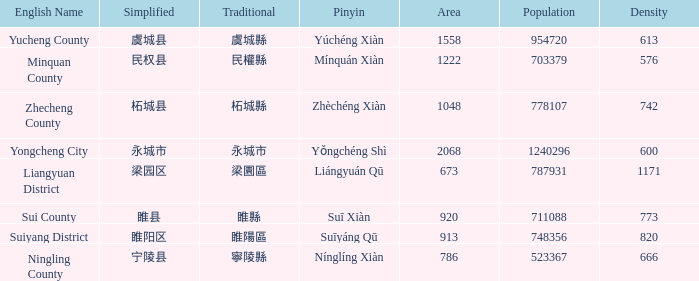How many figures are there for density for Yucheng County? 1.0. Can you parse all the data within this table? {'header': ['English Name', 'Simplified', 'Traditional', 'Pinyin', 'Area', 'Population', 'Density'], 'rows': [['Yucheng County', '虞城县', '虞城縣', 'Yúchéng Xiàn', '1558', '954720', '613'], ['Minquan County', '民权县', '民權縣', 'Mínquán Xiàn', '1222', '703379', '576'], ['Zhecheng County', '柘城县', '柘城縣', 'Zhèchéng Xiàn', '1048', '778107', '742'], ['Yongcheng City', '永城市', '永城市', 'Yǒngchéng Shì', '2068', '1240296', '600'], ['Liangyuan District', '梁园区', '梁園區', 'Liángyuán Qū', '673', '787931', '1171'], ['Sui County', '睢县', '睢縣', 'Suī Xiàn', '920', '711088', '773'], ['Suiyang District', '睢阳区', '睢陽區', 'Suīyáng Qū', '913', '748356', '820'], ['Ningling County', '宁陵县', '寧陵縣', 'Nínglíng Xiàn', '786', '523367', '666']]} 